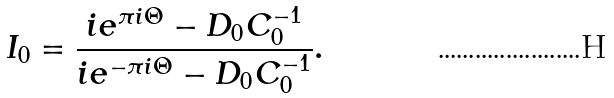Convert formula to latex. <formula><loc_0><loc_0><loc_500><loc_500>I _ { 0 } = \frac { i { e } ^ { \pi i \Theta } - D _ { 0 } C _ { 0 } ^ { - 1 } } { i { e } ^ { - \pi i \Theta } - D _ { 0 } C _ { 0 } ^ { - 1 } } .</formula> 